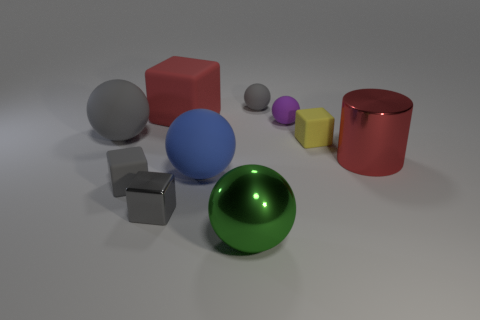There is a object that is the same color as the big cylinder; what is it made of?
Offer a very short reply. Rubber. Is the color of the large metal cylinder the same as the tiny metal thing?
Provide a short and direct response. No. There is a blue thing that is the same size as the green metal sphere; what is its material?
Your answer should be very brief. Rubber. Does the purple sphere have the same material as the big cylinder?
Ensure brevity in your answer.  No. How many cubes are made of the same material as the blue sphere?
Make the answer very short. 3. How many objects are gray rubber things left of the tiny gray matte ball or things to the left of the red cylinder?
Make the answer very short. 9. Is the number of gray matte balls that are behind the big green object greater than the number of small gray metal objects that are right of the small yellow rubber thing?
Ensure brevity in your answer.  Yes. There is a rubber object behind the big red rubber block; what color is it?
Your response must be concise. Gray. Is there a big gray object that has the same shape as the green object?
Your answer should be compact. Yes. How many red objects are either large cylinders or small objects?
Make the answer very short. 1. 